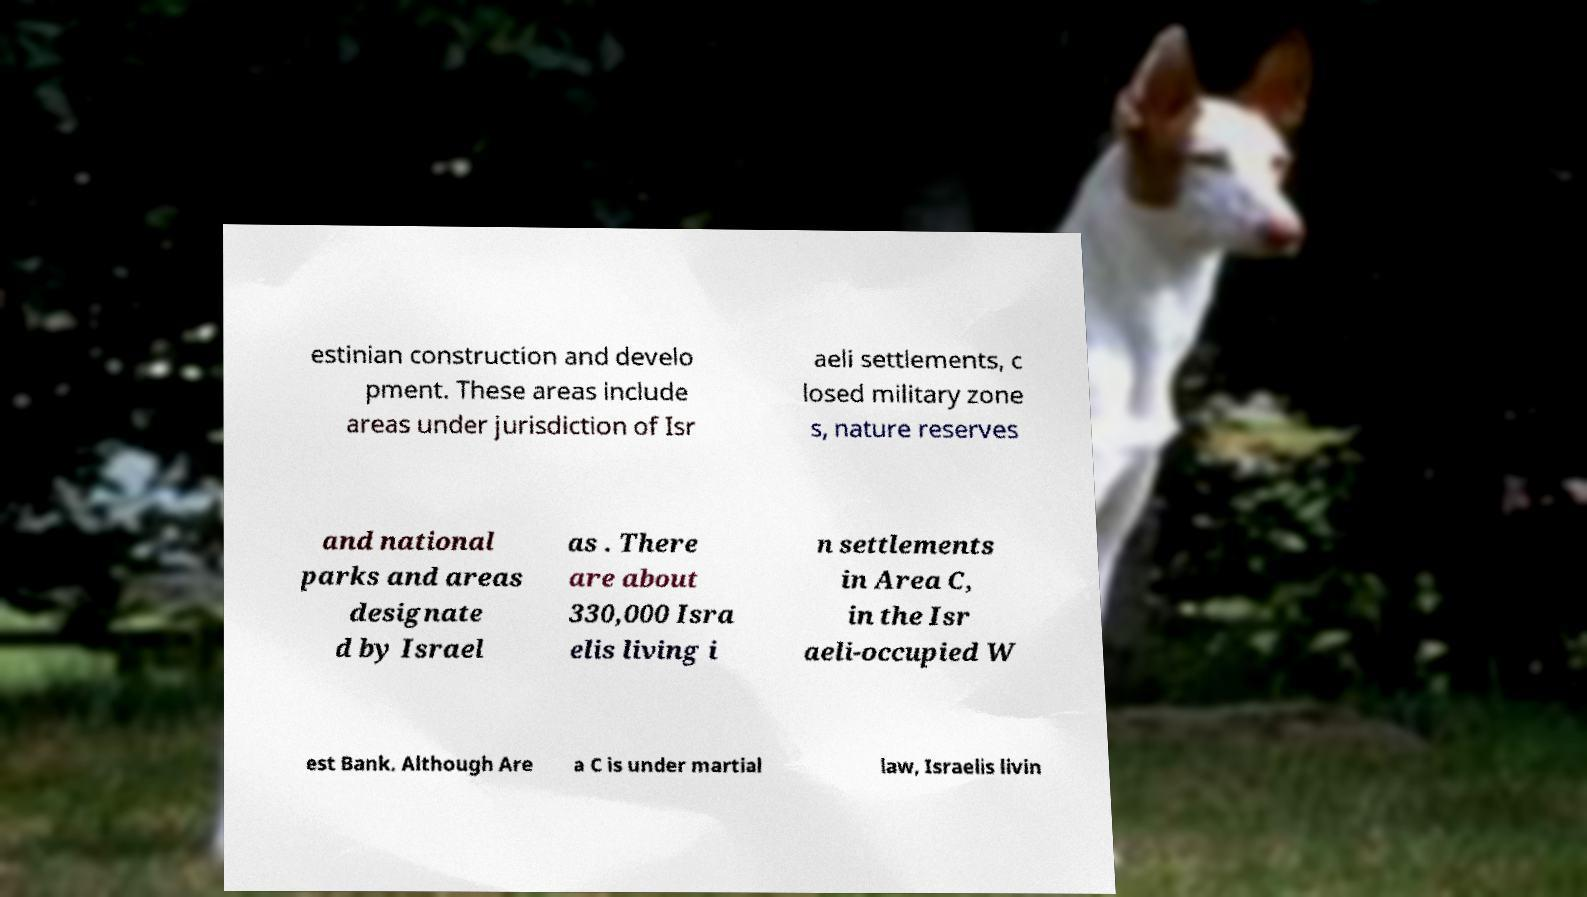I need the written content from this picture converted into text. Can you do that? estinian construction and develo pment. These areas include areas under jurisdiction of Isr aeli settlements, c losed military zone s, nature reserves and national parks and areas designate d by Israel as . There are about 330,000 Isra elis living i n settlements in Area C, in the Isr aeli-occupied W est Bank. Although Are a C is under martial law, Israelis livin 